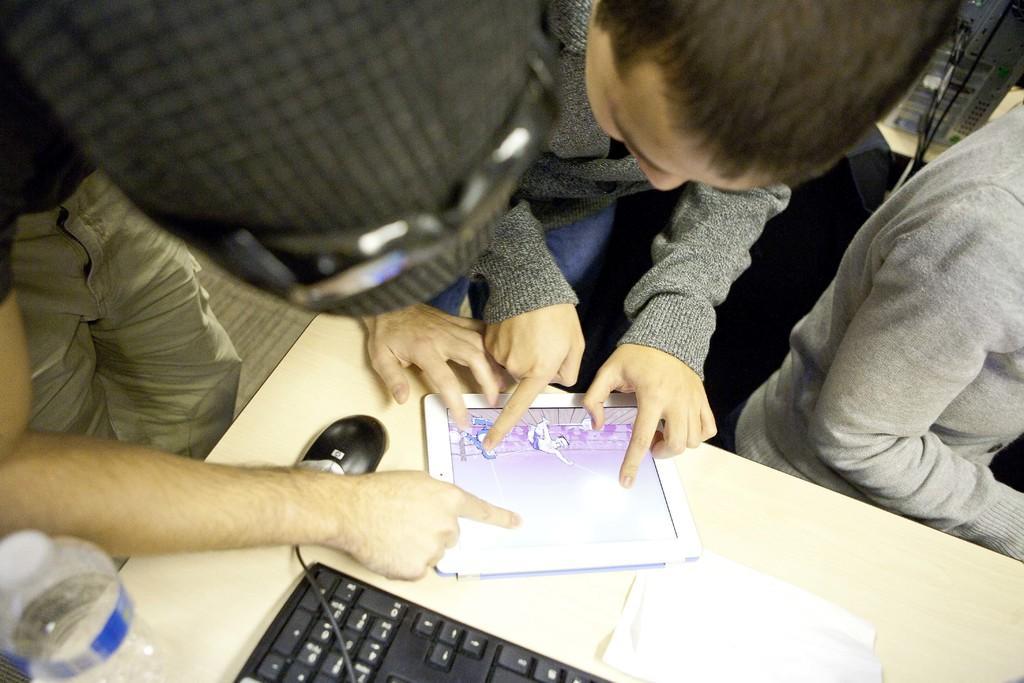In one or two sentences, can you explain what this image depicts? In this picture there are people and we can see gadget, mouse, bottle, cable and paper on the table. In the background of the image we can see device. 